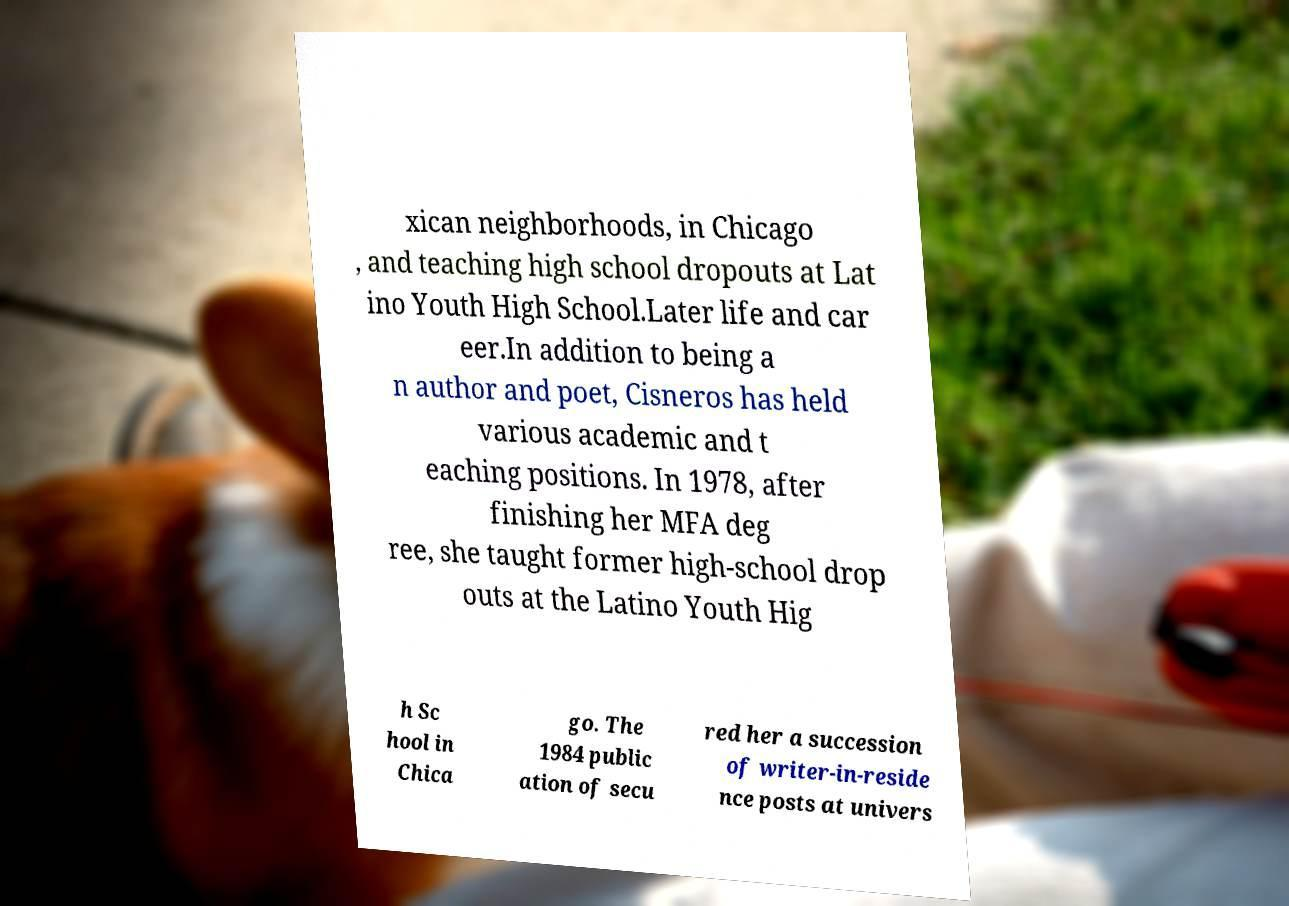Please read and relay the text visible in this image. What does it say? xican neighborhoods, in Chicago , and teaching high school dropouts at Lat ino Youth High School.Later life and car eer.In addition to being a n author and poet, Cisneros has held various academic and t eaching positions. In 1978, after finishing her MFA deg ree, she taught former high-school drop outs at the Latino Youth Hig h Sc hool in Chica go. The 1984 public ation of secu red her a succession of writer-in-reside nce posts at univers 